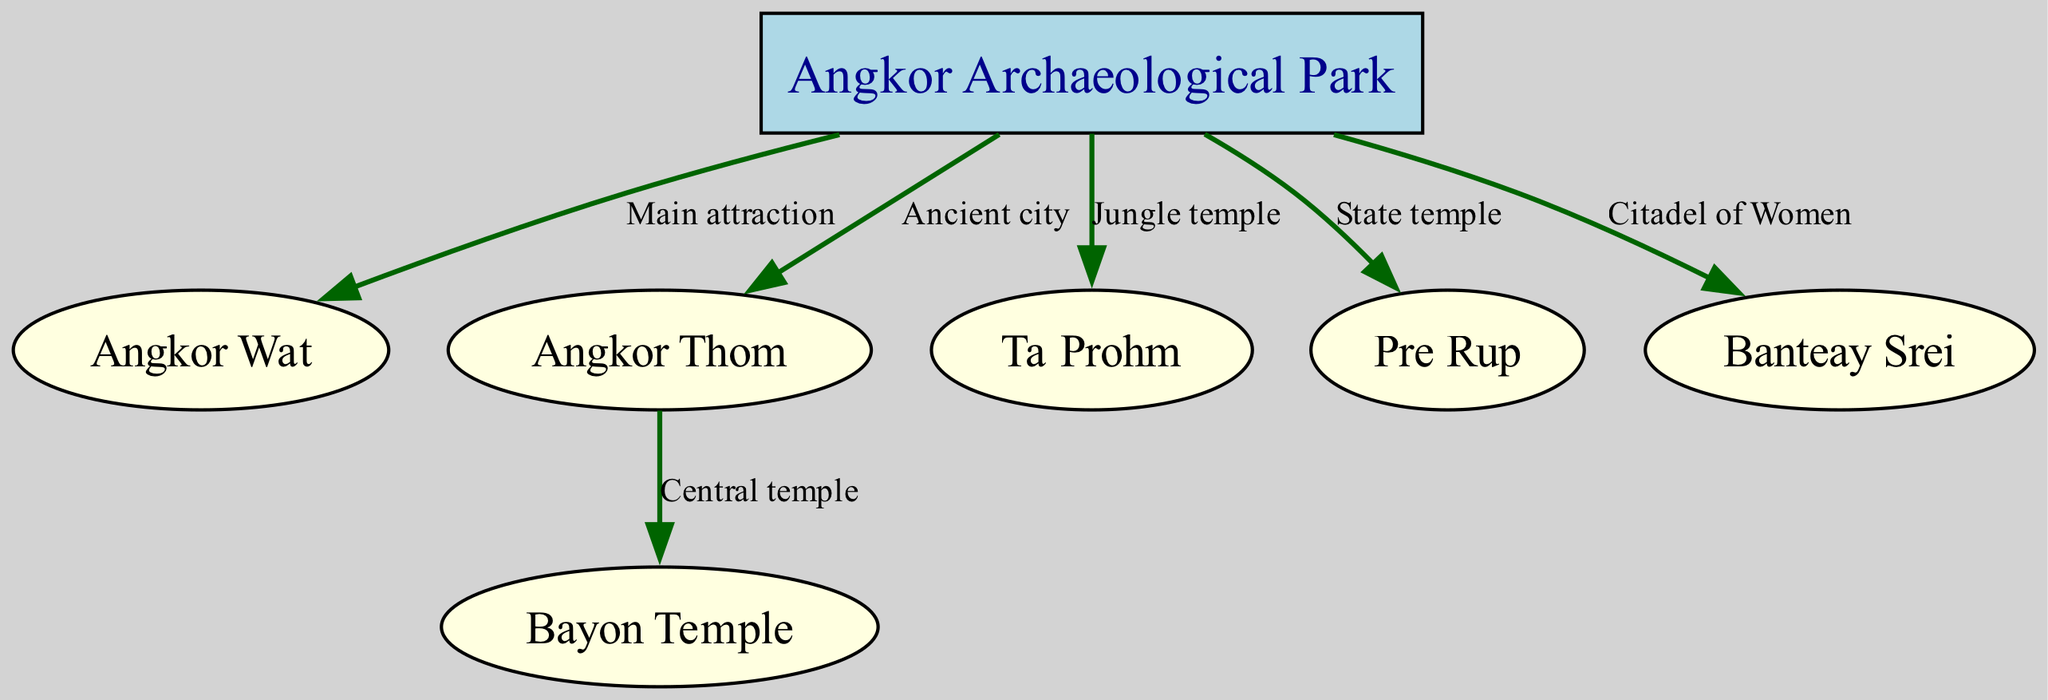What is the main attraction in Angkor Archaeological Park? The diagram indicates that Angkor Wat is labeled as the 'Main attraction' connected by an edge from Angkor Archaeological Park.
Answer: Angkor Wat How many nodes are there in the diagram? By counting the distinct nodes listed in the data, we find a total of 7 locations represented: Angkor Archaeological Park, Angkor Wat, Angkor Thom, Ta Prohm, Bayon Temple, Pre Rup, and Banteay Srei.
Answer: 7 What is Banteay Srei categorized as? The label connecting Banteay Srei to Angkor Archaeological Park describes it as the 'Citadel of Women,' which indicates its cultural context within the hierarchy of the temple complexes.
Answer: Citadel of Women Which temple is the central temple of Angkor Thom? The diagram shows a connection from Angkor Thom to Bayon Temple, labeling Bayon Temple as the 'Central temple', thus identifying its primary role in the hierarchy of temples.
Answer: Bayon Temple What type of temple is Ta Prohm referred to? The diagram distinctly labels Ta Prohm with 'Jungle temple' as its type, emphasizing its unique environmental setting compared to other temples in the park.
Answer: Jungle temple Which temple is directly connected to Angkor Wat? The diagram specifies a direct edge from Angkor Archaeological Park to Angkor Wat, indicating their direct relationship within the structured hierarchy of the complexes.
Answer: Angkor Wat What is the relationship between Angkor Thom and Bayon Temple? The diagram explicitly states that Angkor Thom connects to Bayon Temple with the label 'Central temple', illustrating Bayon Temple's position within the context of Angkor Thom.
Answer: Central temple What type of temple is Pre Rup identified as? According to the diagram, Pre Rup is categorized with the label 'State temple', denoting its significance and function within the temple complex hierarchy.
Answer: State temple What is the relationship between Angkor Archaeological Park and Angkor Thom? The directed edge from Angkor Archaeological Park to Angkor Thom is labeled 'Ancient city', which highlights the historical context and importance of Angkor Thom within the park.
Answer: Ancient city 